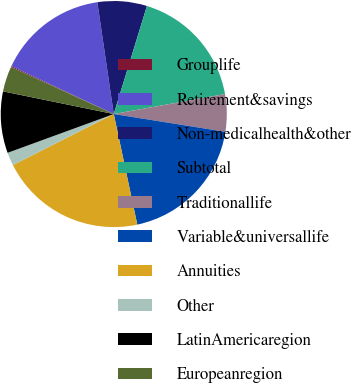<chart> <loc_0><loc_0><loc_500><loc_500><pie_chart><fcel>Grouplife<fcel>Retirement&savings<fcel>Non-medicalhealth&other<fcel>Subtotal<fcel>Traditionallife<fcel>Variable&universallife<fcel>Annuities<fcel>Other<fcel>LatinAmericaregion<fcel>Europeanregion<nl><fcel>0.15%<fcel>15.7%<fcel>7.06%<fcel>17.43%<fcel>5.34%<fcel>19.15%<fcel>20.88%<fcel>1.88%<fcel>8.79%<fcel>3.61%<nl></chart> 